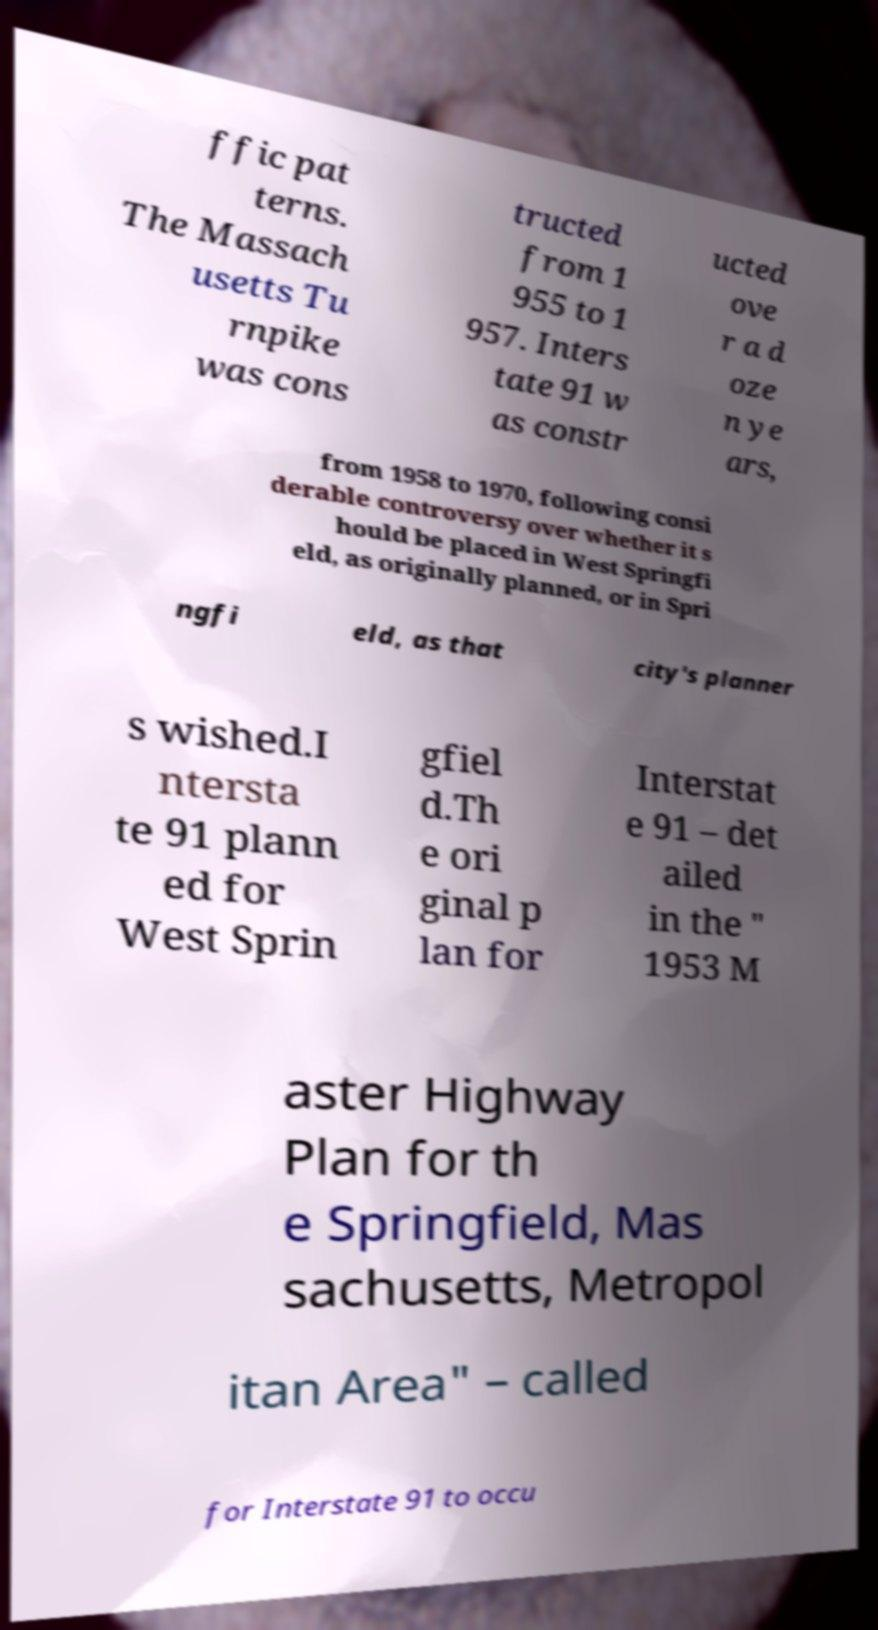For documentation purposes, I need the text within this image transcribed. Could you provide that? ffic pat terns. The Massach usetts Tu rnpike was cons tructed from 1 955 to 1 957. Inters tate 91 w as constr ucted ove r a d oze n ye ars, from 1958 to 1970, following consi derable controversy over whether it s hould be placed in West Springfi eld, as originally planned, or in Spri ngfi eld, as that city's planner s wished.I ntersta te 91 plann ed for West Sprin gfiel d.Th e ori ginal p lan for Interstat e 91 – det ailed in the " 1953 M aster Highway Plan for th e Springfield, Mas sachusetts, Metropol itan Area" – called for Interstate 91 to occu 